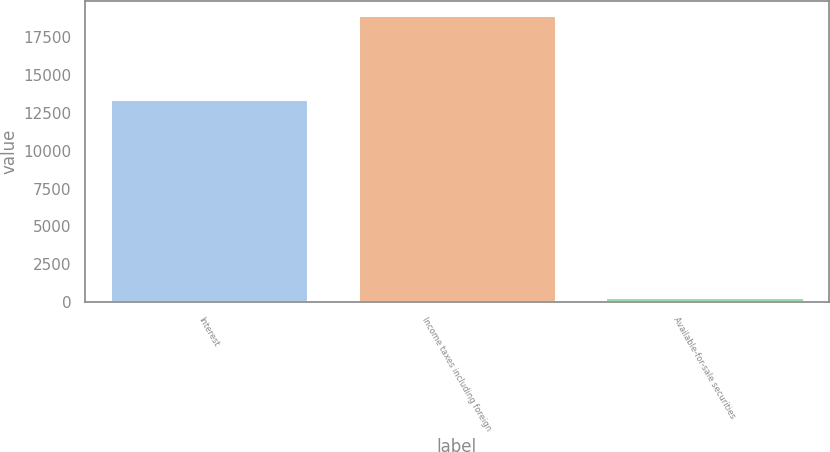<chart> <loc_0><loc_0><loc_500><loc_500><bar_chart><fcel>Interest<fcel>Income taxes including foreign<fcel>Available-for-sale securities<nl><fcel>13417<fcel>18961<fcel>352<nl></chart> 